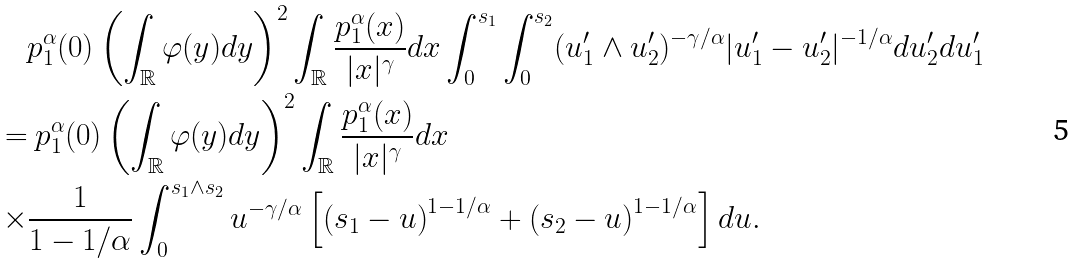<formula> <loc_0><loc_0><loc_500><loc_500>& p ^ { \alpha } _ { 1 } ( 0 ) \left ( \int _ { \mathbb { R } } \varphi ( y ) d y \right ) ^ { 2 } \int _ { \mathbb { R } } \frac { p ^ { \alpha } _ { 1 } ( x ) } { | x | ^ { \gamma } } d x \int _ { 0 } ^ { s _ { 1 } } \int _ { 0 } ^ { s _ { 2 } } ( u ^ { \prime } _ { 1 } \wedge u ^ { \prime } _ { 2 } ) ^ { - \gamma / \alpha } | u ^ { \prime } _ { 1 } - u ^ { \prime } _ { 2 } | ^ { - 1 / \alpha } d u ^ { \prime } _ { 2 } d u ^ { \prime } _ { 1 } \\ = & \ p ^ { \alpha } _ { 1 } ( 0 ) \left ( \int _ { \mathbb { R } } \varphi ( y ) d y \right ) ^ { 2 } \int _ { \mathbb { R } } \frac { p ^ { \alpha } _ { 1 } ( x ) } { | x | ^ { \gamma } } d x \\ \times & \frac { 1 } { 1 - 1 / \alpha } \int _ { 0 } ^ { s _ { 1 } \wedge s _ { 2 } } u ^ { - \gamma / \alpha } \left [ \left ( s _ { 1 } - u \right ) ^ { 1 - 1 / \alpha } + \left ( s _ { 2 } - u \right ) ^ { 1 - 1 / \alpha } \right ] d u .</formula> 